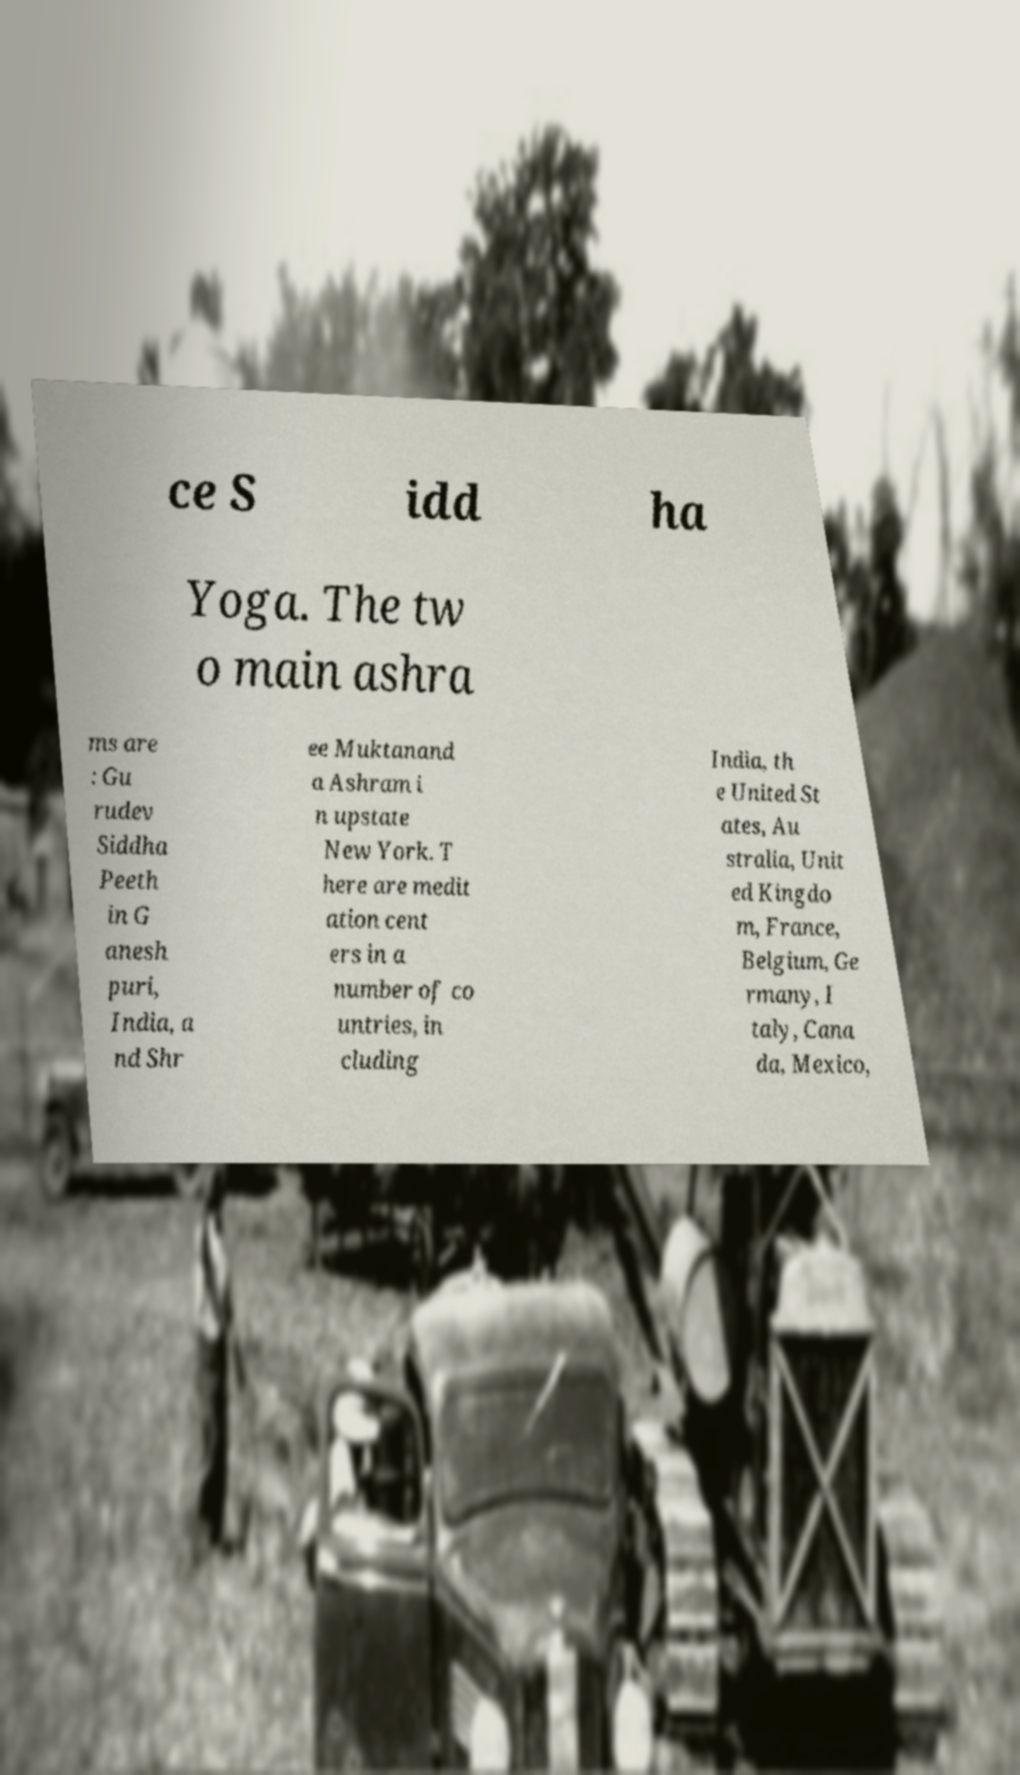Could you extract and type out the text from this image? ce S idd ha Yoga. The tw o main ashra ms are : Gu rudev Siddha Peeth in G anesh puri, India, a nd Shr ee Muktanand a Ashram i n upstate New York. T here are medit ation cent ers in a number of co untries, in cluding India, th e United St ates, Au stralia, Unit ed Kingdo m, France, Belgium, Ge rmany, I taly, Cana da, Mexico, 